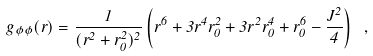<formula> <loc_0><loc_0><loc_500><loc_500>g _ { \phi \phi } ( r ) = \frac { 1 } { ( r ^ { 2 } + r _ { 0 } ^ { 2 } ) ^ { 2 } } \left ( r ^ { 6 } + 3 r ^ { 4 } r _ { 0 } ^ { 2 } + 3 r ^ { 2 } r _ { 0 } ^ { 4 } + r _ { 0 } ^ { 6 } - \frac { J ^ { 2 } } { 4 } \right ) \ , \label l { t i m e l i k e }</formula> 